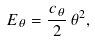Convert formula to latex. <formula><loc_0><loc_0><loc_500><loc_500>E _ { \theta } = \frac { c _ { \theta } } { 2 } \, \theta ^ { 2 } ,</formula> 